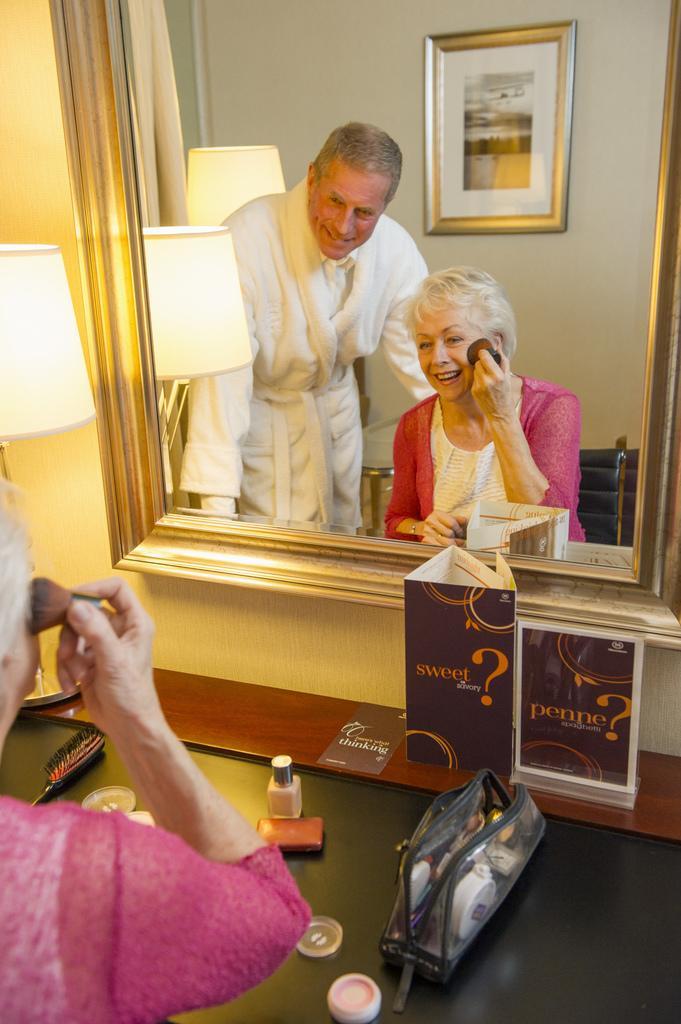Describe this image in one or two sentences. In the bottom left there is a woman wearing pink color dress. In front of this woman there is a table on which a bag, brush and some other objects are placed. At the top there is a mirror attached to the wall. In the mirror, I can see this woman is smiling and beside her there is a man standing, smiling and looking at the mirror. Beside the mirror there is a lamp. In the background there is a frame attached to the wall. 